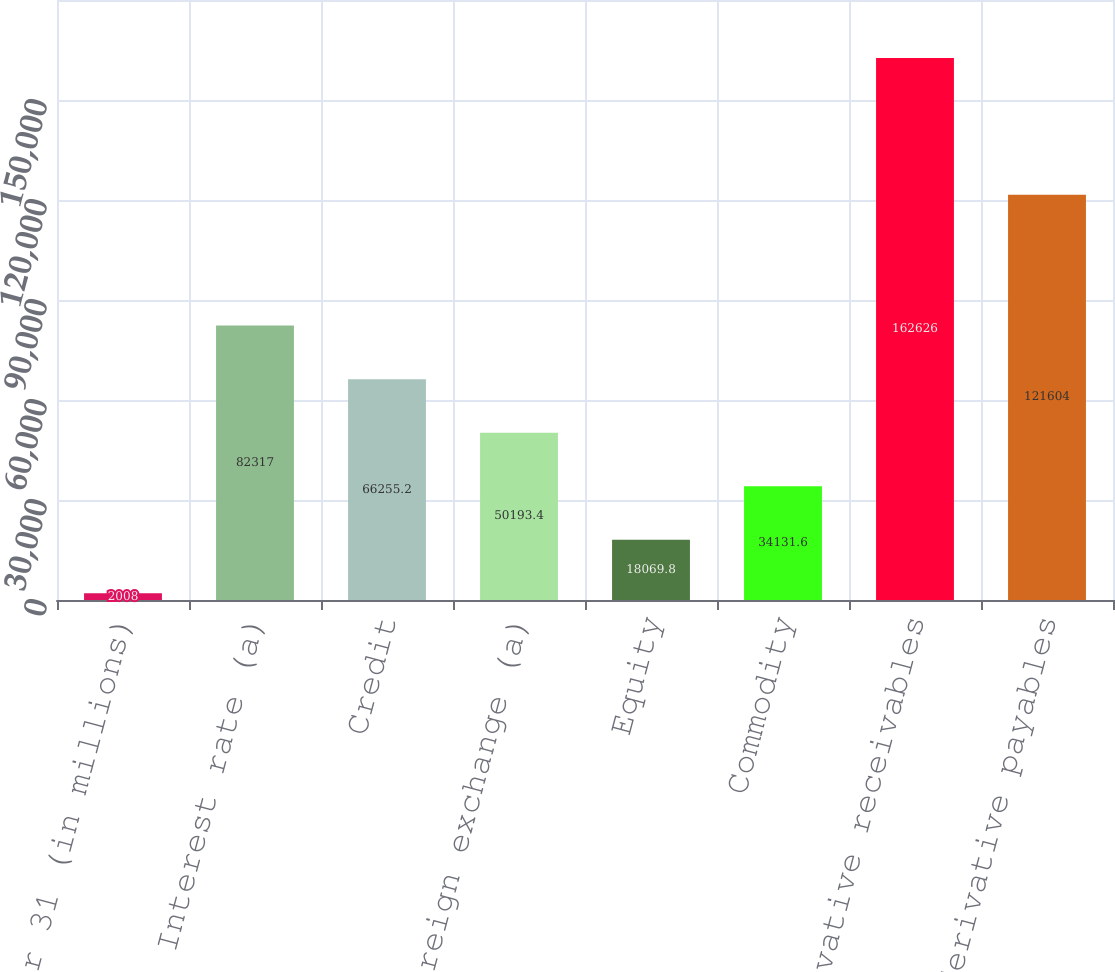<chart> <loc_0><loc_0><loc_500><loc_500><bar_chart><fcel>December 31 (in millions)<fcel>Interest rate (a)<fcel>Credit<fcel>Foreign exchange (a)<fcel>Equity<fcel>Commodity<fcel>Total derivative receivables<fcel>Total derivative payables<nl><fcel>2008<fcel>82317<fcel>66255.2<fcel>50193.4<fcel>18069.8<fcel>34131.6<fcel>162626<fcel>121604<nl></chart> 